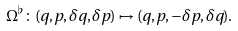Convert formula to latex. <formula><loc_0><loc_0><loc_500><loc_500>\Omega ^ { \flat } \colon ( q , p , \delta q , \delta p ) \mapsto ( q , p , - \delta p , \delta q ) .</formula> 